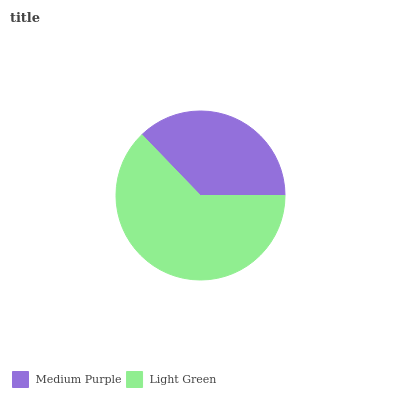Is Medium Purple the minimum?
Answer yes or no. Yes. Is Light Green the maximum?
Answer yes or no. Yes. Is Light Green the minimum?
Answer yes or no. No. Is Light Green greater than Medium Purple?
Answer yes or no. Yes. Is Medium Purple less than Light Green?
Answer yes or no. Yes. Is Medium Purple greater than Light Green?
Answer yes or no. No. Is Light Green less than Medium Purple?
Answer yes or no. No. Is Light Green the high median?
Answer yes or no. Yes. Is Medium Purple the low median?
Answer yes or no. Yes. Is Medium Purple the high median?
Answer yes or no. No. Is Light Green the low median?
Answer yes or no. No. 